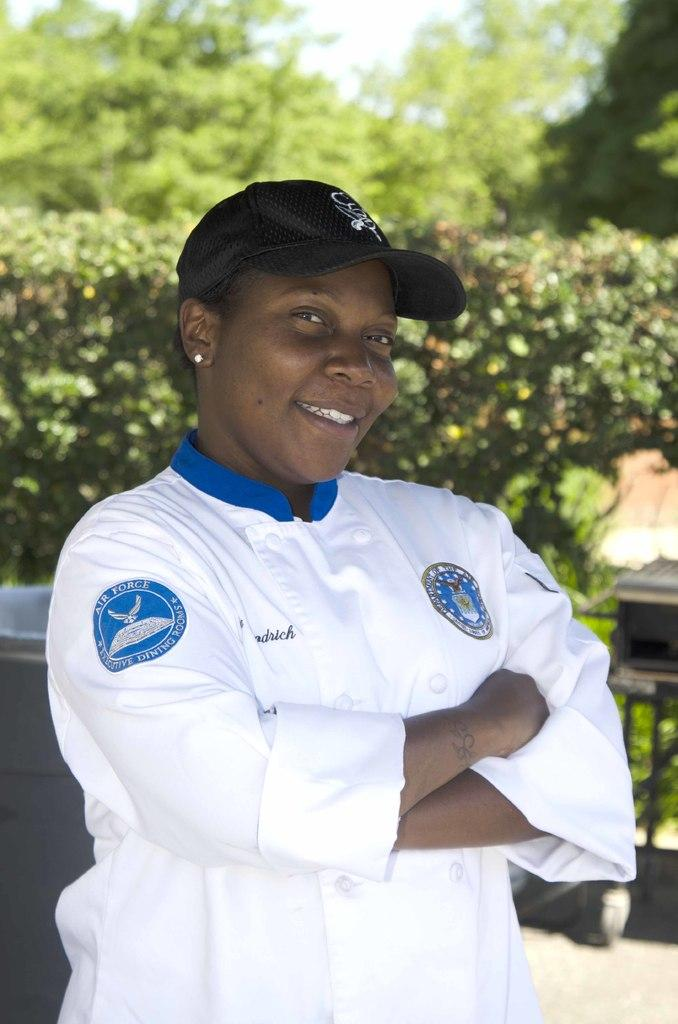Who is present in the image? There is a woman in the image. What is the woman wearing? The woman is wearing a white dress and a black cap. Where is the woman standing? The woman is standing on the floor. What can be seen in the background of the image? There is a group of trees and the sky visible in the background of the image. What type of pies can be seen on the ground in the image? There are no pies present in the image; the woman is standing on the floor, but no pies are visible. 